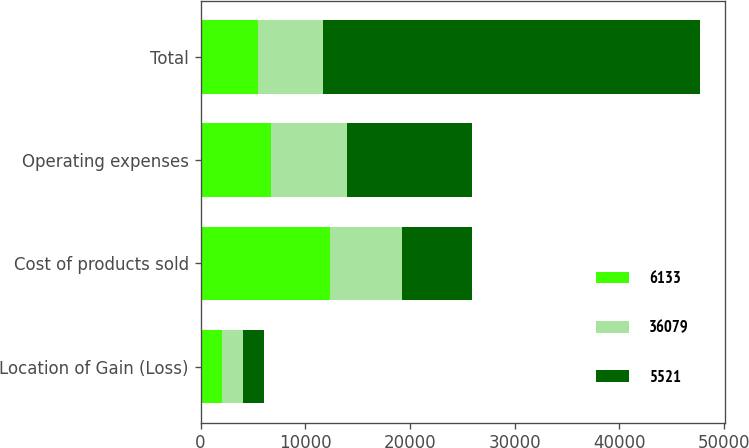Convert chart to OTSL. <chart><loc_0><loc_0><loc_500><loc_500><stacked_bar_chart><ecel><fcel>Location of Gain (Loss)<fcel>Cost of products sold<fcel>Operating expenses<fcel>Total<nl><fcel>6133<fcel>2017<fcel>12327<fcel>6697<fcel>5521<nl><fcel>36079<fcel>2016<fcel>6889<fcel>7276<fcel>6133<nl><fcel>5521<fcel>2015<fcel>6697<fcel>12003<fcel>36079<nl></chart> 